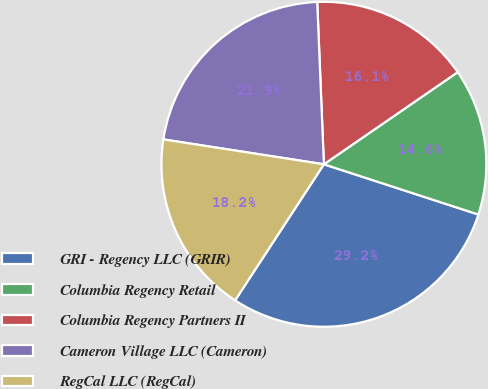Convert chart. <chart><loc_0><loc_0><loc_500><loc_500><pie_chart><fcel>GRI - Regency LLC (GRIR)<fcel>Columbia Regency Retail<fcel>Columbia Regency Partners II<fcel>Cameron Village LLC (Cameron)<fcel>RegCal LLC (RegCal)<nl><fcel>29.2%<fcel>14.6%<fcel>16.06%<fcel>21.9%<fcel>18.25%<nl></chart> 